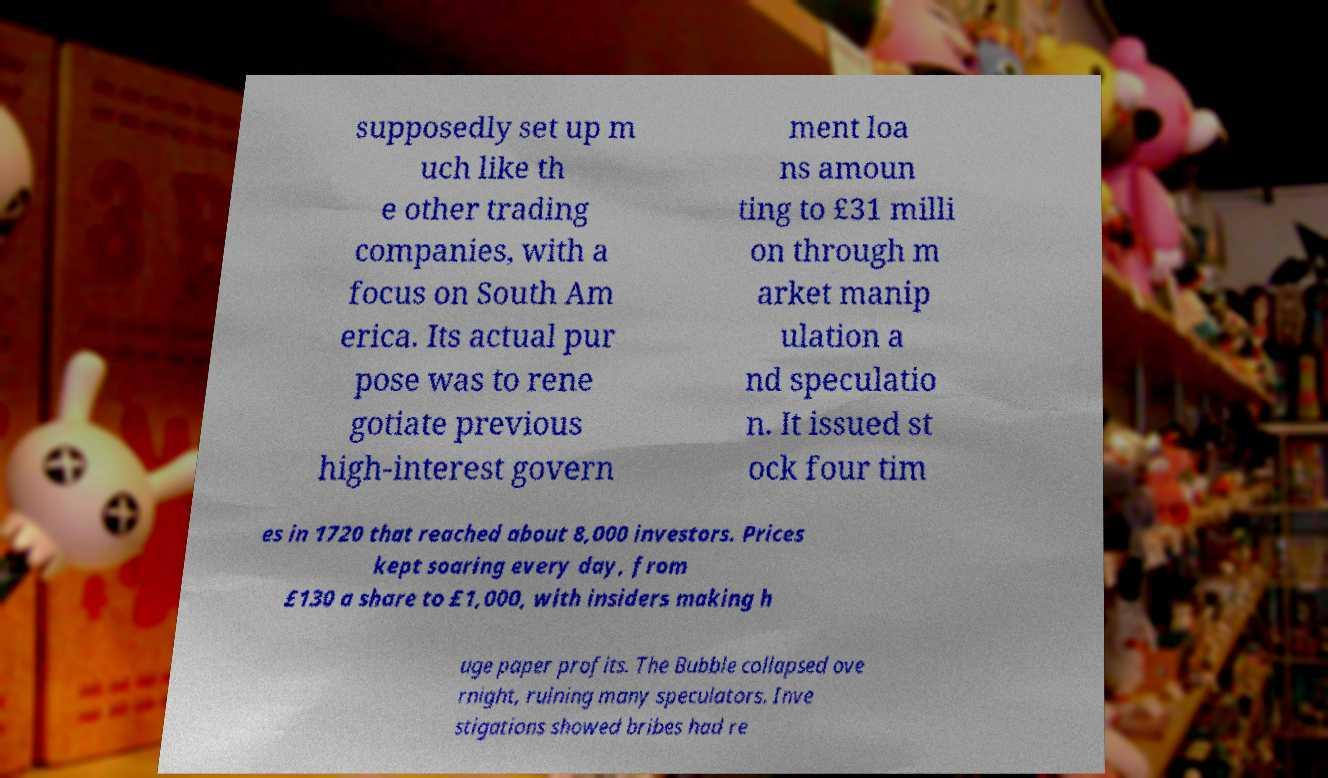For documentation purposes, I need the text within this image transcribed. Could you provide that? supposedly set up m uch like th e other trading companies, with a focus on South Am erica. Its actual pur pose was to rene gotiate previous high-interest govern ment loa ns amoun ting to £31 milli on through m arket manip ulation a nd speculatio n. It issued st ock four tim es in 1720 that reached about 8,000 investors. Prices kept soaring every day, from £130 a share to £1,000, with insiders making h uge paper profits. The Bubble collapsed ove rnight, ruining many speculators. Inve stigations showed bribes had re 